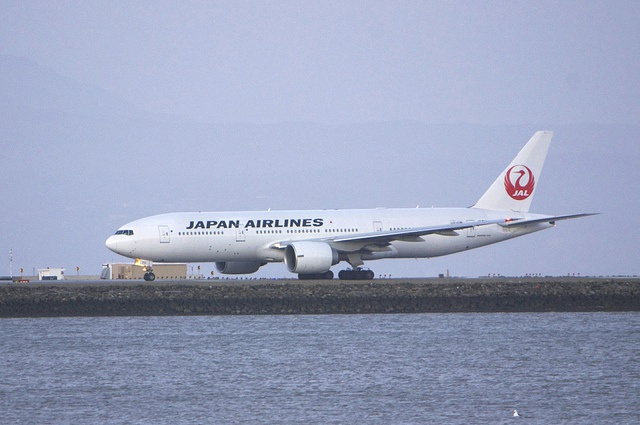Describe the objects in this image and their specific colors. I can see a airplane in darkgray, lavender, and gray tones in this image. 